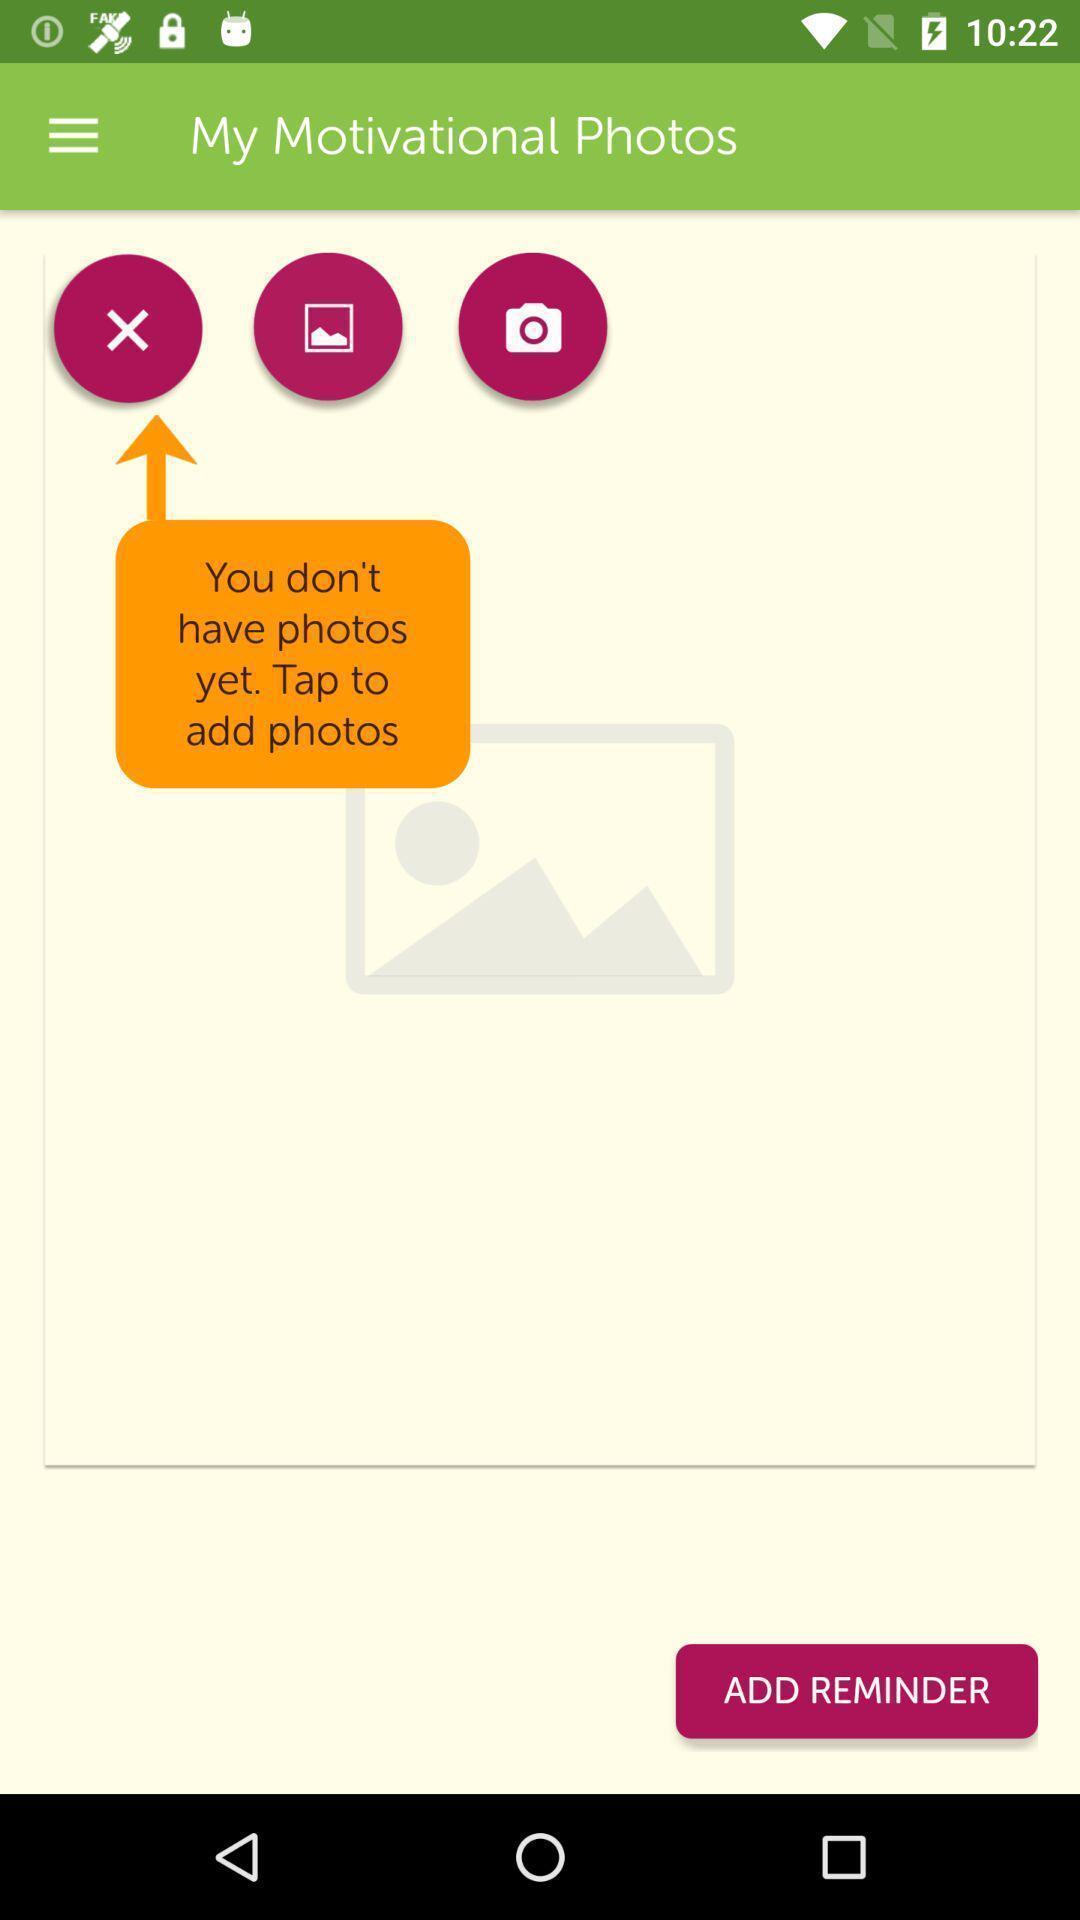Explain what's happening in this screen capture. Page shows motivational photos with few options in health app. 